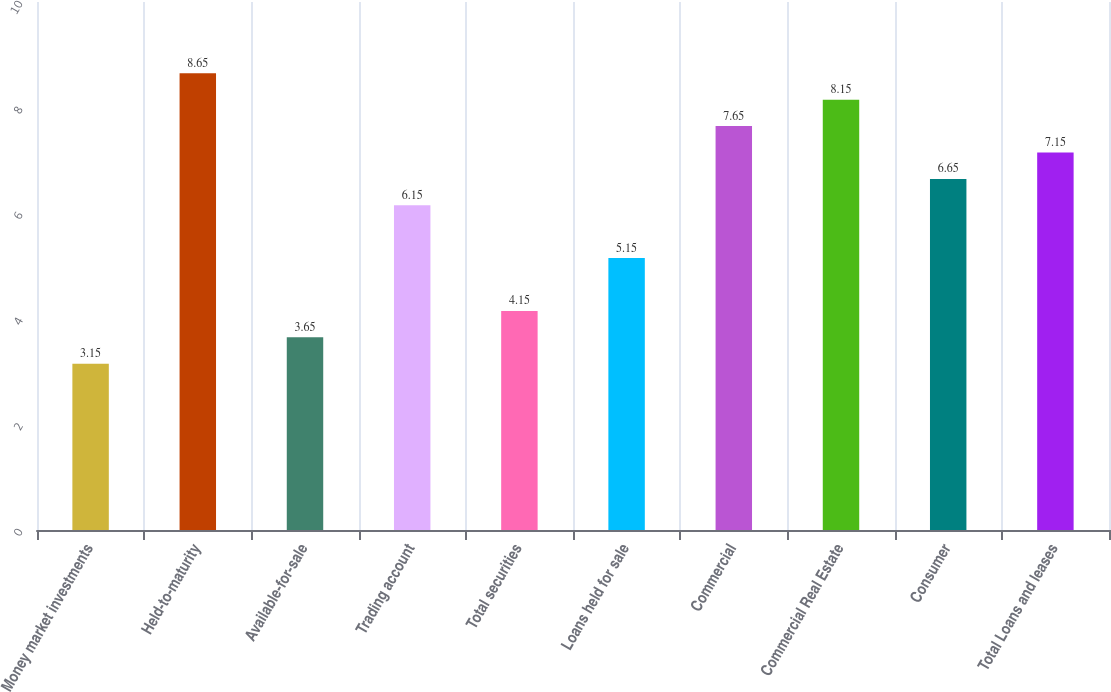Convert chart. <chart><loc_0><loc_0><loc_500><loc_500><bar_chart><fcel>Money market investments<fcel>Held-to-maturity<fcel>Available-for-sale<fcel>Trading account<fcel>Total securities<fcel>Loans held for sale<fcel>Commercial<fcel>Commercial Real Estate<fcel>Consumer<fcel>Total Loans and leases<nl><fcel>3.15<fcel>8.65<fcel>3.65<fcel>6.15<fcel>4.15<fcel>5.15<fcel>7.65<fcel>8.15<fcel>6.65<fcel>7.15<nl></chart> 